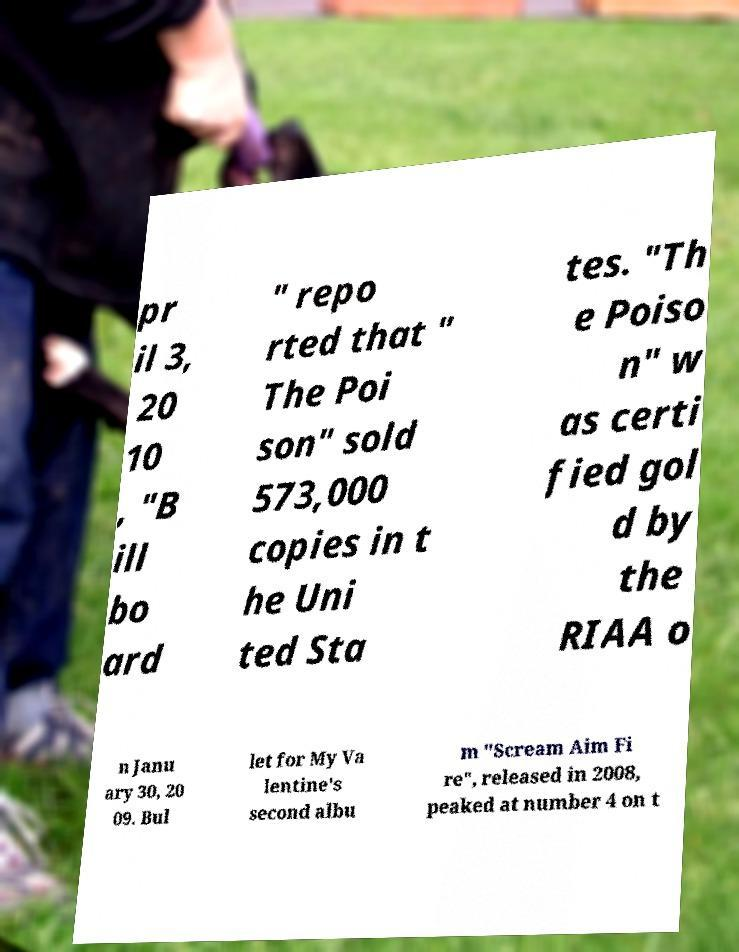Could you assist in decoding the text presented in this image and type it out clearly? pr il 3, 20 10 , "B ill bo ard " repo rted that " The Poi son" sold 573,000 copies in t he Uni ted Sta tes. "Th e Poiso n" w as certi fied gol d by the RIAA o n Janu ary 30, 20 09. Bul let for My Va lentine's second albu m "Scream Aim Fi re", released in 2008, peaked at number 4 on t 